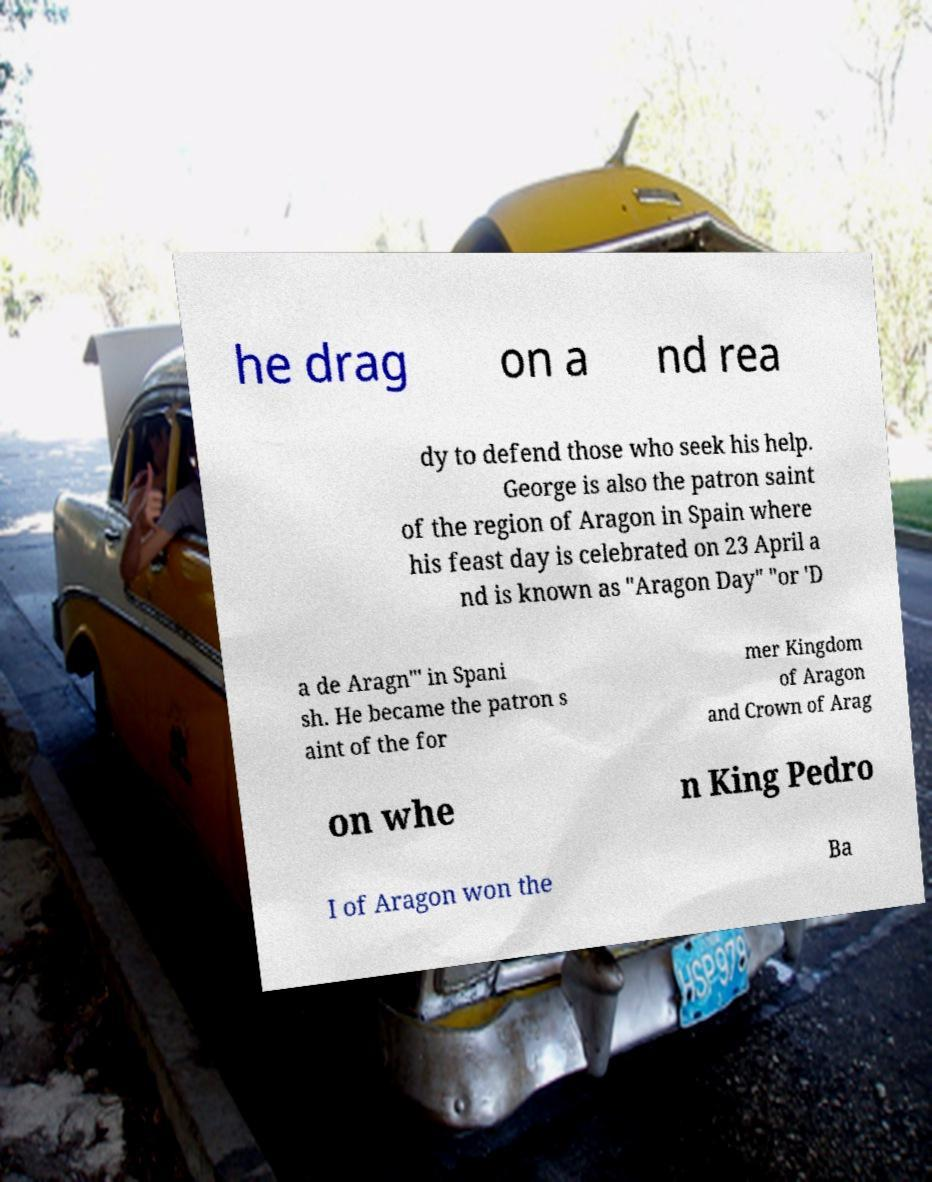Could you assist in decoding the text presented in this image and type it out clearly? he drag on a nd rea dy to defend those who seek his help. George is also the patron saint of the region of Aragon in Spain where his feast day is celebrated on 23 April a nd is known as "Aragon Day" "or 'D a de Aragn"' in Spani sh. He became the patron s aint of the for mer Kingdom of Aragon and Crown of Arag on whe n King Pedro I of Aragon won the Ba 